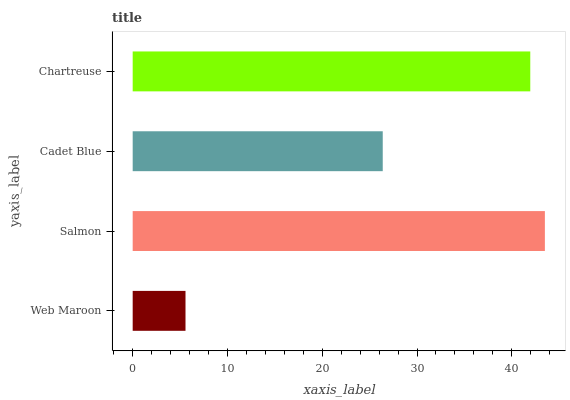Is Web Maroon the minimum?
Answer yes or no. Yes. Is Salmon the maximum?
Answer yes or no. Yes. Is Cadet Blue the minimum?
Answer yes or no. No. Is Cadet Blue the maximum?
Answer yes or no. No. Is Salmon greater than Cadet Blue?
Answer yes or no. Yes. Is Cadet Blue less than Salmon?
Answer yes or no. Yes. Is Cadet Blue greater than Salmon?
Answer yes or no. No. Is Salmon less than Cadet Blue?
Answer yes or no. No. Is Chartreuse the high median?
Answer yes or no. Yes. Is Cadet Blue the low median?
Answer yes or no. Yes. Is Web Maroon the high median?
Answer yes or no. No. Is Salmon the low median?
Answer yes or no. No. 